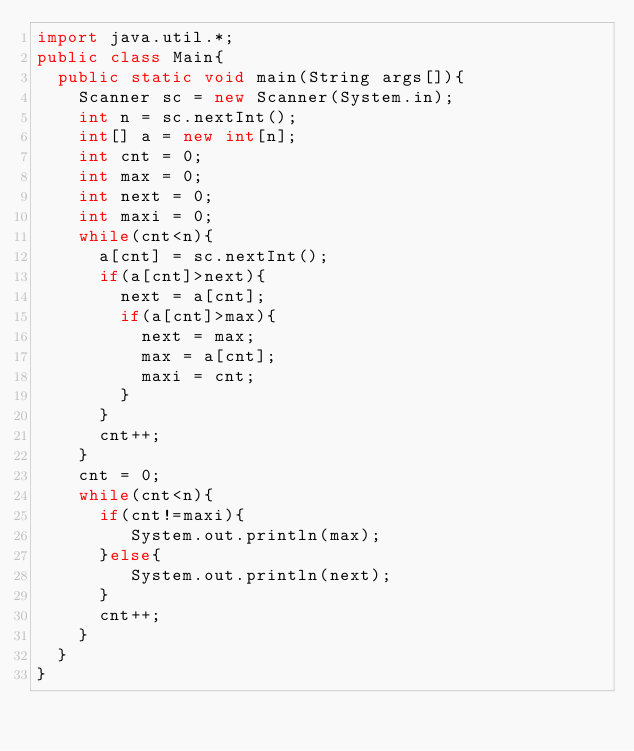<code> <loc_0><loc_0><loc_500><loc_500><_Java_>import java.util.*;
public class Main{
  public static void main(String args[]){
    Scanner sc = new Scanner(System.in);
    int n = sc.nextInt();
    int[] a = new int[n];
    int cnt = 0;
    int max = 0;
    int next = 0;
    int maxi = 0;
    while(cnt<n){
      a[cnt] = sc.nextInt();
      if(a[cnt]>next){
        next = a[cnt];
        if(a[cnt]>max){
          next = max;
          max = a[cnt];
          maxi = cnt;
        }
      }
      cnt++;
    }
    cnt = 0;
    while(cnt<n){
      if(cnt!=maxi){
         System.out.println(max);
      }else{
         System.out.println(next);
      }
      cnt++;
    }
  } 
}</code> 